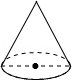What might be the use of this cone-shaped object in a real-world application? This cone-shaped mold could be used in various fields, such as in baking to shape dough or in construction and ceramics to mold materials like clay. It's also possible that it's used in educational settings to demonstrate geometrical principles and volume calculations. 